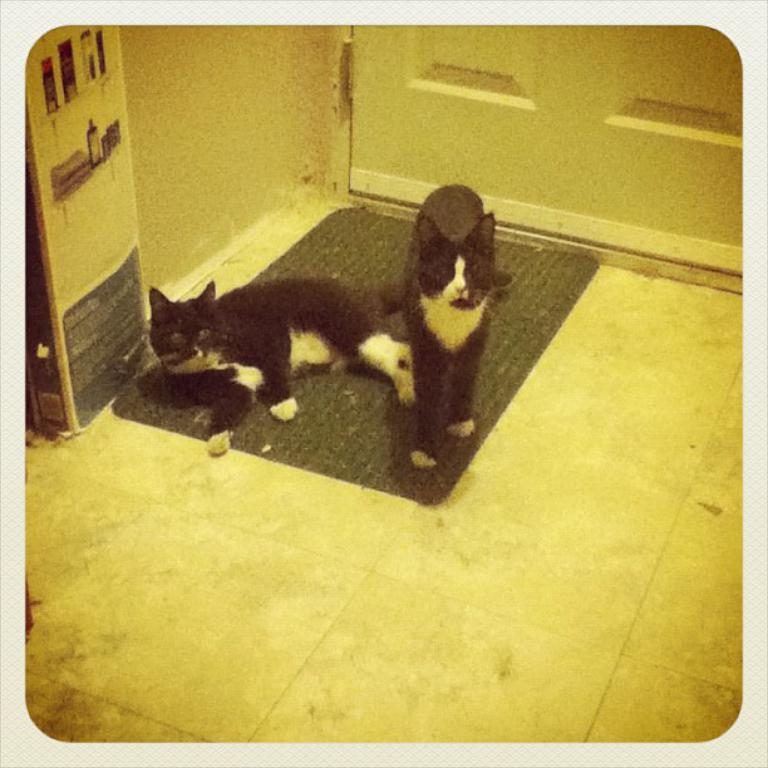How many cats are present in the image? There are two cats in the image. Where are the cats located? The cats are on the floor in the image. What is present on the floor in the image? There is a floor mat in the image. What other objects can be seen in the image? There is a board and a wall in the image. What type of image is this? The image appears to be a photo frame. What type of soda is being poured onto the snow in the image? There is no soda or snow present in the image; it features two cats on a floor mat with a board and a wall in the background. 